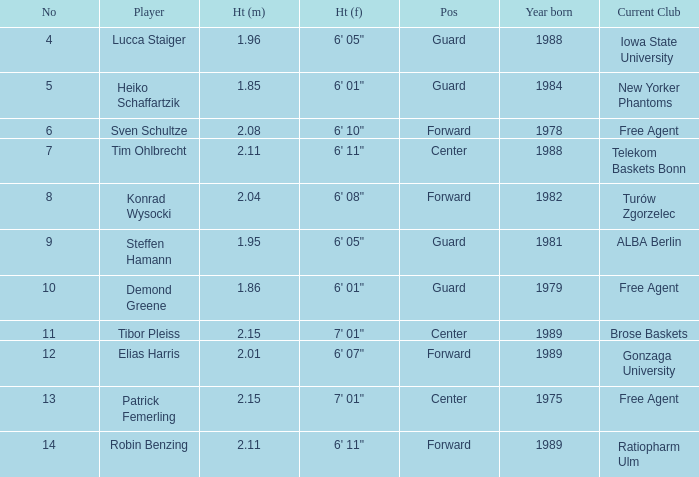Name the height for the player born 1989 and height 2.11 6' 11". 